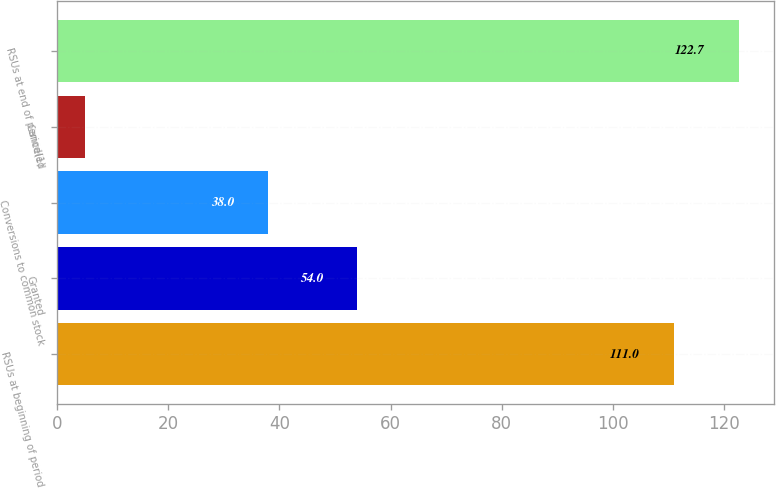Convert chart to OTSL. <chart><loc_0><loc_0><loc_500><loc_500><bar_chart><fcel>RSUs at beginning of period<fcel>Granted<fcel>Conversions to common stock<fcel>Canceled<fcel>RSUs at end of period(1)<nl><fcel>111<fcel>54<fcel>38<fcel>5<fcel>122.7<nl></chart> 